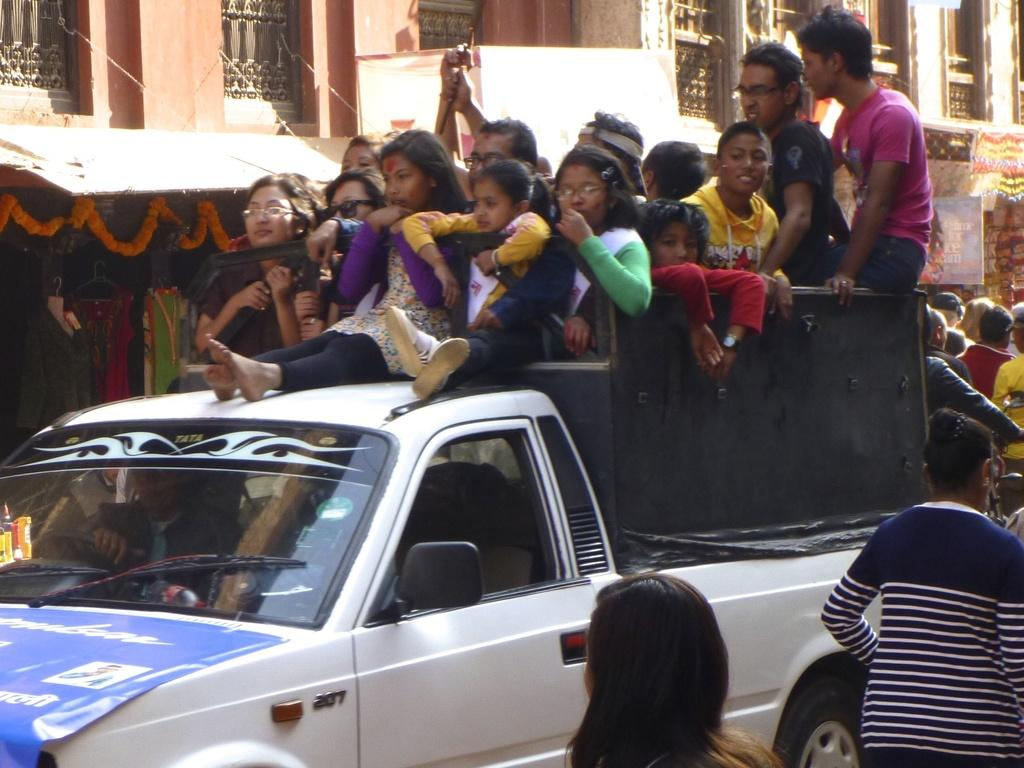What are the persons in the image doing? The persons in the image are on a vehicle. What can be seen in the image besides the persons on the vehicle? There is a banner, a door, buildings, a wall, flowers, and dresses in the image. How many holes can be seen in the image? There is no mention of any holes in the image, so it is not possible to determine the number of holes present. 